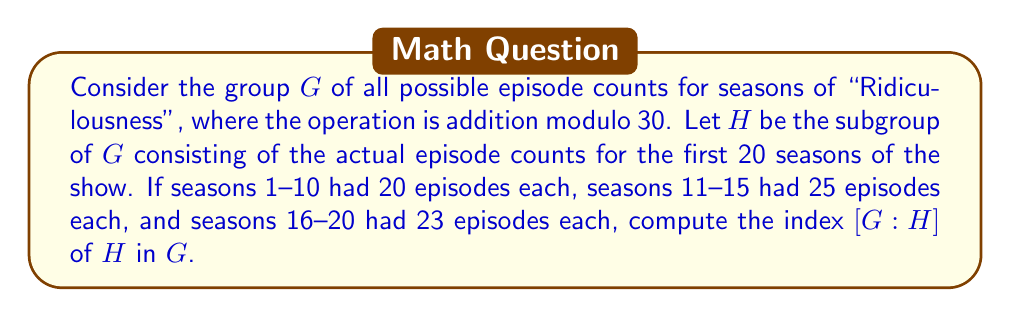Give your solution to this math problem. To solve this problem, we need to follow these steps:

1) First, we need to determine the order of group $G$. Since the operation is addition modulo 30, $G$ consists of all integers from 0 to 29. Thus, $|G| = 30$.

2) Next, we need to find the elements of subgroup $H$. $H$ consists of the actual episode counts:
   - 20 (for seasons 1-10)
   - 25 (for seasons 11-15)
   - 23 (for seasons 16-20)

3) $H = \{20, 25, 23\}$ under addition modulo 30.

4) To find $|H|$, we need to generate all elements by combining these numbers under the group operation:
   20 + 20 ≡ 10 (mod 30)
   20 + 25 ≡ 15 (mod 30)
   20 + 23 ≡ 13 (mod 30)
   25 + 25 ≡ 20 (mod 30)
   25 + 23 ≡ 18 (mod 30)
   23 + 23 ≡ 16 (mod 30)

5) Therefore, $H = \{20, 25, 23, 10, 15, 13, 18, 16\}$

6) $|H| = 8$

7) The index $[G:H]$ is defined as $\frac{|G|}{|H|}$

8) Therefore, $[G:H] = \frac{30}{8} = \frac{15}{4}$
Answer: $[G:H] = \frac{15}{4}$ 